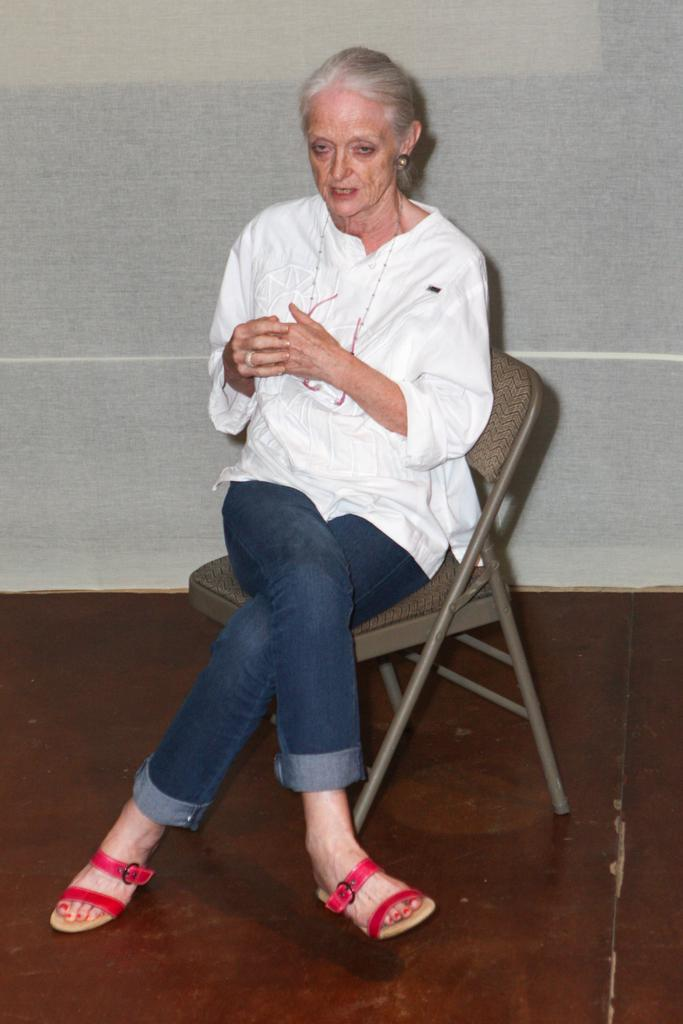What is the woman doing in the image? The woman is sitting on a chair in the image. Where is the chair located? The chair is on the floor. What can be seen in the background of the image? There is a transparent cloth and an unspecified object in the background of the image. What is the condition of the hammer in the image? There is no hammer present in the image. 